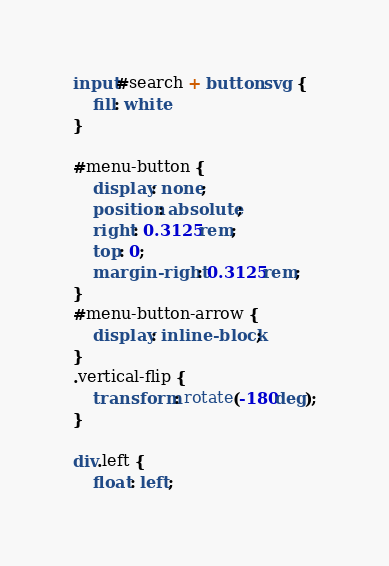<code> <loc_0><loc_0><loc_500><loc_500><_CSS_>input#search + button svg {
	fill: white
}

#menu-button {
	display: none;
	position: absolute;
	right: 0.3125rem;
	top: 0;
	margin-right: 0.3125rem;
}
#menu-button-arrow {
	display: inline-block;
}
.vertical-flip {
	transform: rotate(-180deg);
}

div.left {
	float: left;</code> 